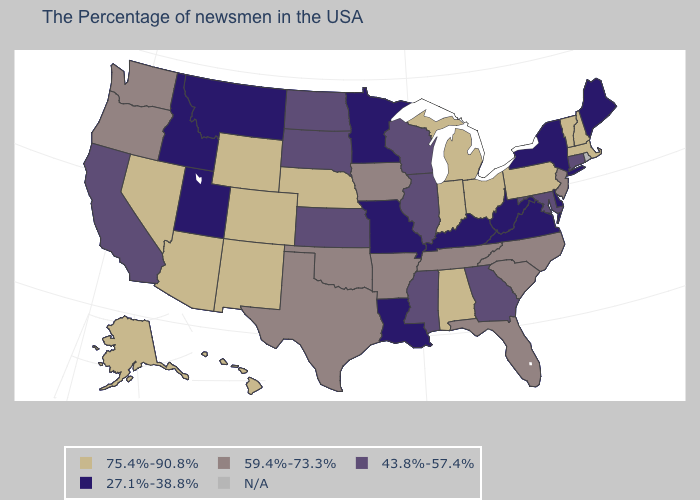Name the states that have a value in the range 27.1%-38.8%?
Concise answer only. Maine, New York, Delaware, Virginia, West Virginia, Kentucky, Louisiana, Missouri, Minnesota, Utah, Montana, Idaho. Name the states that have a value in the range 27.1%-38.8%?
Keep it brief. Maine, New York, Delaware, Virginia, West Virginia, Kentucky, Louisiana, Missouri, Minnesota, Utah, Montana, Idaho. Name the states that have a value in the range 27.1%-38.8%?
Write a very short answer. Maine, New York, Delaware, Virginia, West Virginia, Kentucky, Louisiana, Missouri, Minnesota, Utah, Montana, Idaho. What is the highest value in the Northeast ?
Answer briefly. 75.4%-90.8%. Name the states that have a value in the range N/A?
Answer briefly. Rhode Island. What is the lowest value in the MidWest?
Be succinct. 27.1%-38.8%. What is the lowest value in the USA?
Concise answer only. 27.1%-38.8%. Name the states that have a value in the range N/A?
Short answer required. Rhode Island. What is the value of Wyoming?
Concise answer only. 75.4%-90.8%. What is the value of Minnesota?
Quick response, please. 27.1%-38.8%. Among the states that border Arkansas , which have the lowest value?
Be succinct. Louisiana, Missouri. 